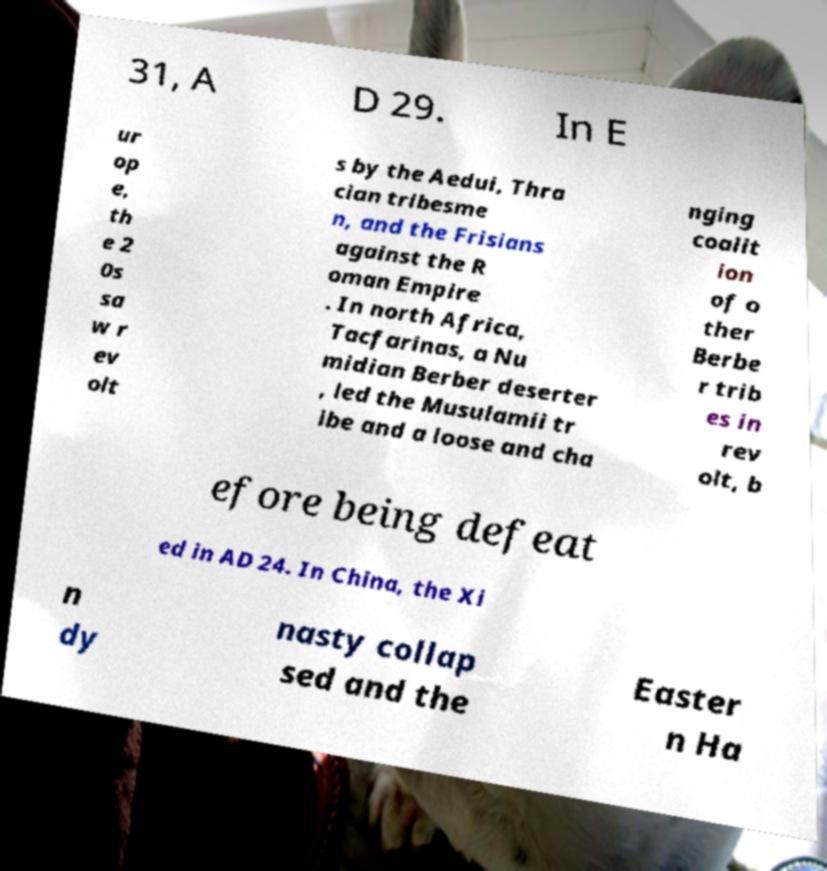Can you read and provide the text displayed in the image?This photo seems to have some interesting text. Can you extract and type it out for me? 31, A D 29. In E ur op e, th e 2 0s sa w r ev olt s by the Aedui, Thra cian tribesme n, and the Frisians against the R oman Empire . In north Africa, Tacfarinas, a Nu midian Berber deserter , led the Musulamii tr ibe and a loose and cha nging coalit ion of o ther Berbe r trib es in rev olt, b efore being defeat ed in AD 24. In China, the Xi n dy nasty collap sed and the Easter n Ha 